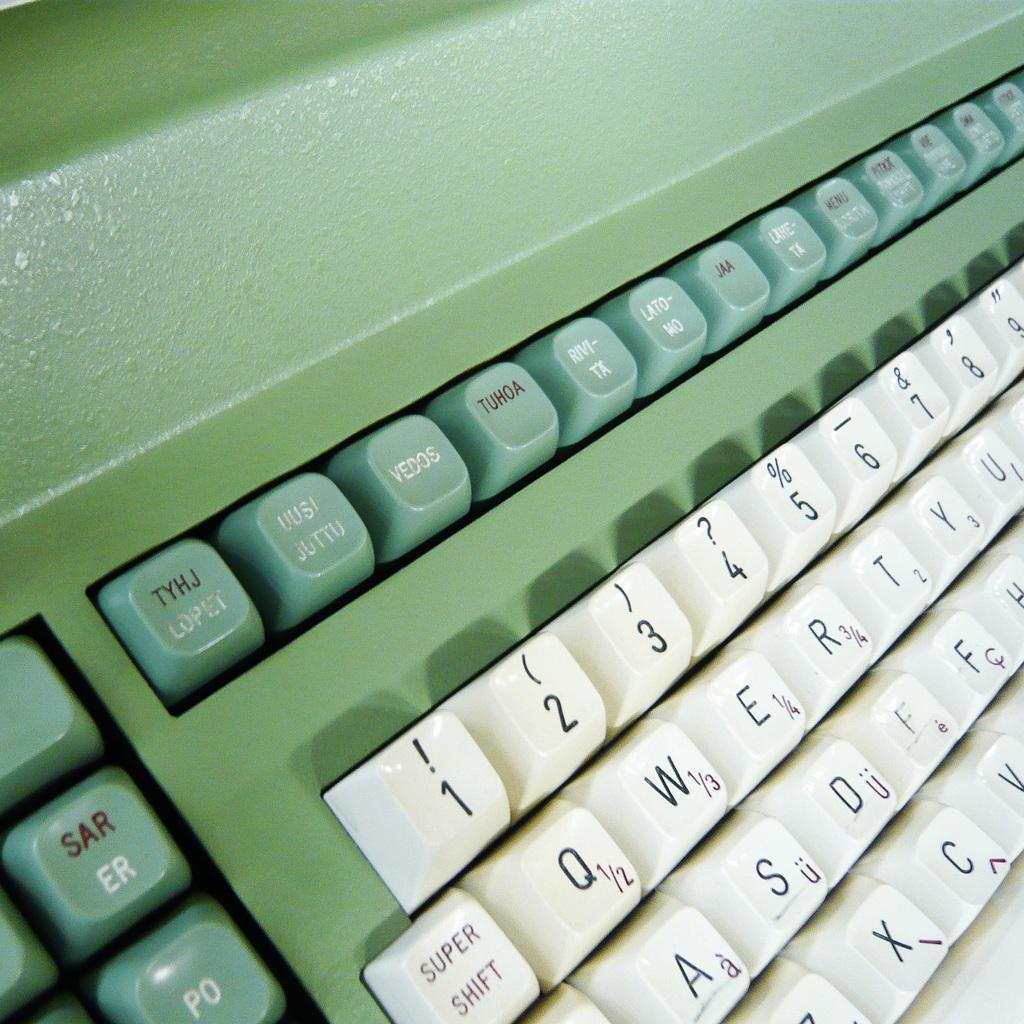What is the first number on the top white colored keys?
Make the answer very short. 1. 